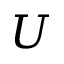<formula> <loc_0><loc_0><loc_500><loc_500>U</formula> 